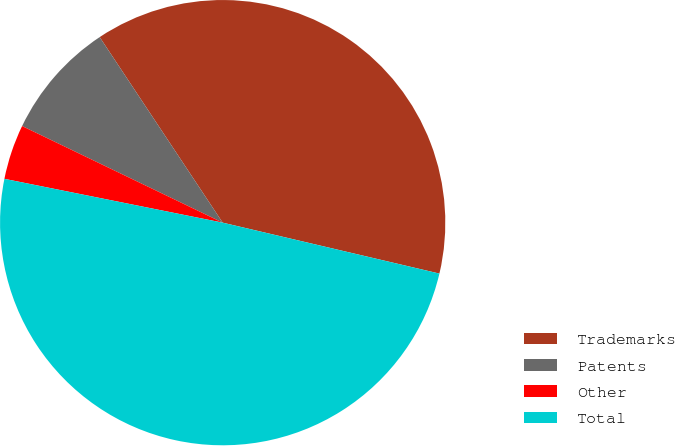Convert chart to OTSL. <chart><loc_0><loc_0><loc_500><loc_500><pie_chart><fcel>Trademarks<fcel>Patents<fcel>Other<fcel>Total<nl><fcel>37.99%<fcel>8.54%<fcel>3.99%<fcel>49.48%<nl></chart> 